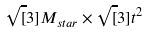<formula> <loc_0><loc_0><loc_500><loc_500>\sqrt { [ } 3 ] { M _ { s t a r } } \times \sqrt { [ } 3 ] { t ^ { 2 } }</formula> 